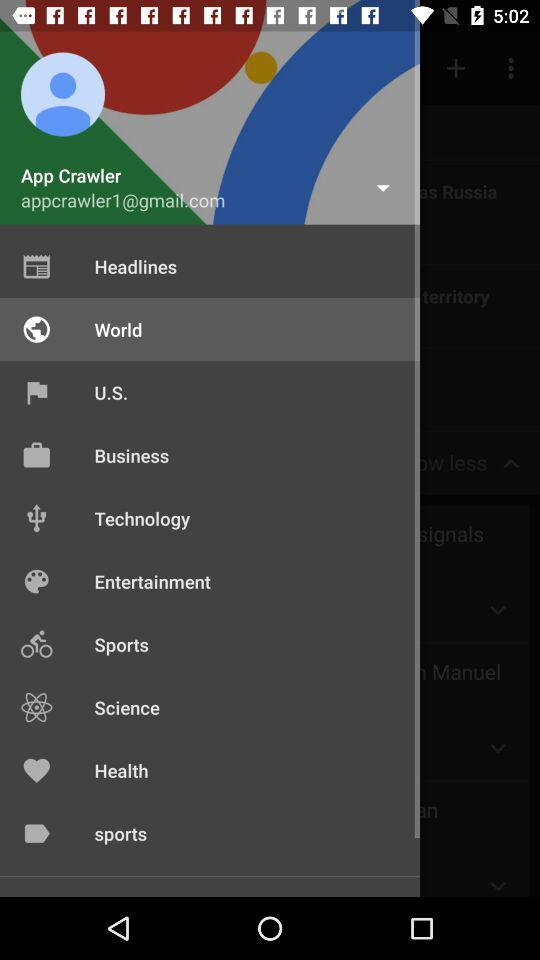Which item is selected? The selected item is "World". 